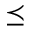Convert formula to latex. <formula><loc_0><loc_0><loc_500><loc_500>\preceq</formula> 